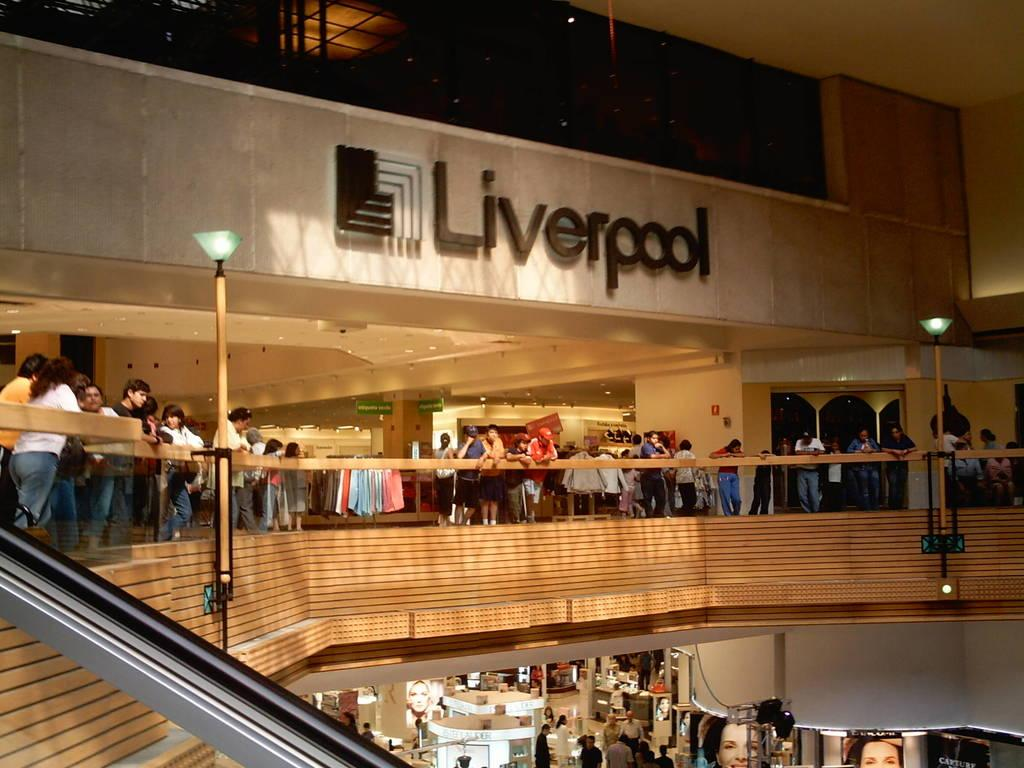What type of location is depicted in the image? The image appears to depict a mall. Can you describe any text visible in the image? There is text visible in the image, but it is not clear what it says. What can be seen in the image besides the location? There are people, clothes, stalls, a wooden railing, and wooden poles with lights present in the image. What type of cream is being applied to the wooden railing in the image? There is no cream being applied to the wooden railing in the image; it is a stationary object. 